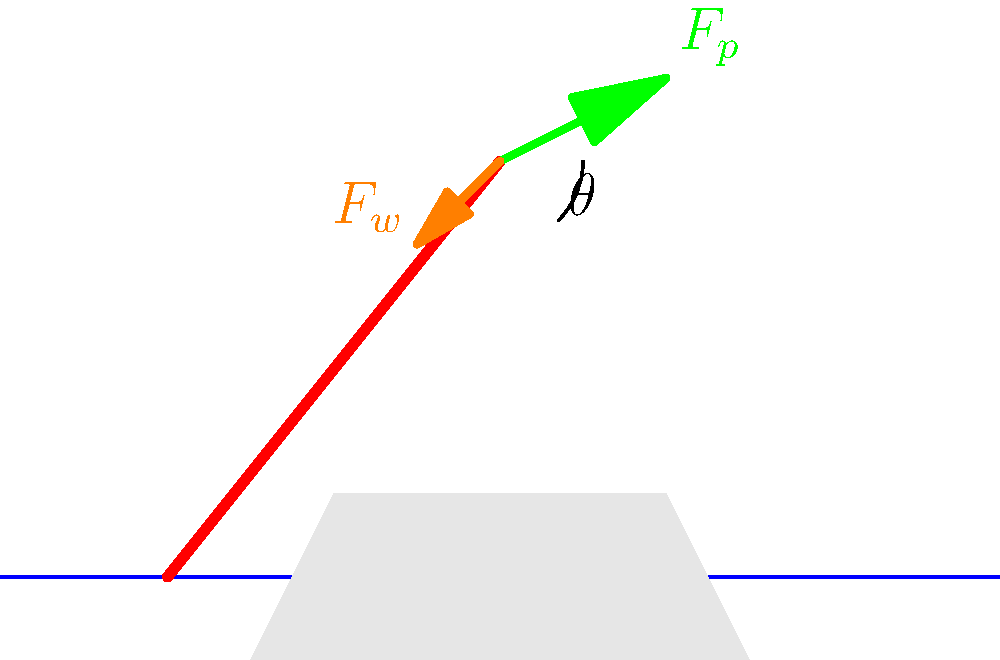As a professional kayaker, you're analyzing the optimal angle for a paddle stroke. The diagram shows a simplified force analysis of a kayak paddle during a stroke. $F_p$ represents the force applied by the paddler, and $F_w$ is the resistance force from the water. If the magnitude of $F_p$ is 200 N and $F_w$ is 150 N, what is the optimal angle $\theta$ (in degrees) between the paddle and the water surface to maximize forward propulsion? To find the optimal angle for maximum forward propulsion, we need to follow these steps:

1) The forward propulsion is maximized when the resultant force is parallel to the water surface.

2) This occurs when the vertical components of $F_p$ and $F_w$ cancel each other out.

3) We can express this condition mathematically:

   $F_p \sin \theta = F_w \cos \theta$

4) Rearranging the equation:

   $\tan \theta = \frac{F_w}{F_p}$

5) Substituting the given values:

   $\tan \theta = \frac{150 \text{ N}}{200 \text{ N}} = 0.75$

6) To find $\theta$, we take the inverse tangent (arctan) of both sides:

   $\theta = \arctan(0.75)$

7) Calculate the result:

   $\theta \approx 36.87°$

Therefore, the optimal angle for maximum forward propulsion is approximately 36.87 degrees.
Answer: $36.87°$ 